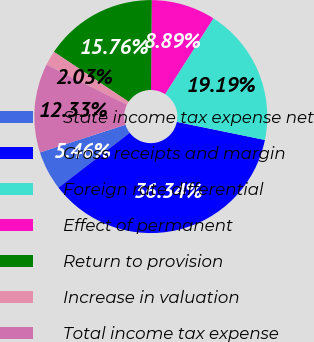<chart> <loc_0><loc_0><loc_500><loc_500><pie_chart><fcel>State income tax expense net<fcel>Gross receipts and margin<fcel>Foreign rate differential<fcel>Effect of permanent<fcel>Return to provision<fcel>Increase in valuation<fcel>Total income tax expense<nl><fcel>5.46%<fcel>36.34%<fcel>19.19%<fcel>8.89%<fcel>15.76%<fcel>2.03%<fcel>12.33%<nl></chart> 